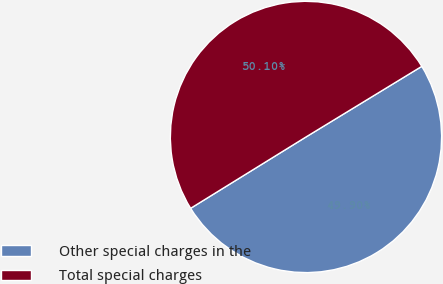<chart> <loc_0><loc_0><loc_500><loc_500><pie_chart><fcel>Other special charges in the<fcel>Total special charges<nl><fcel>49.9%<fcel>50.1%<nl></chart> 